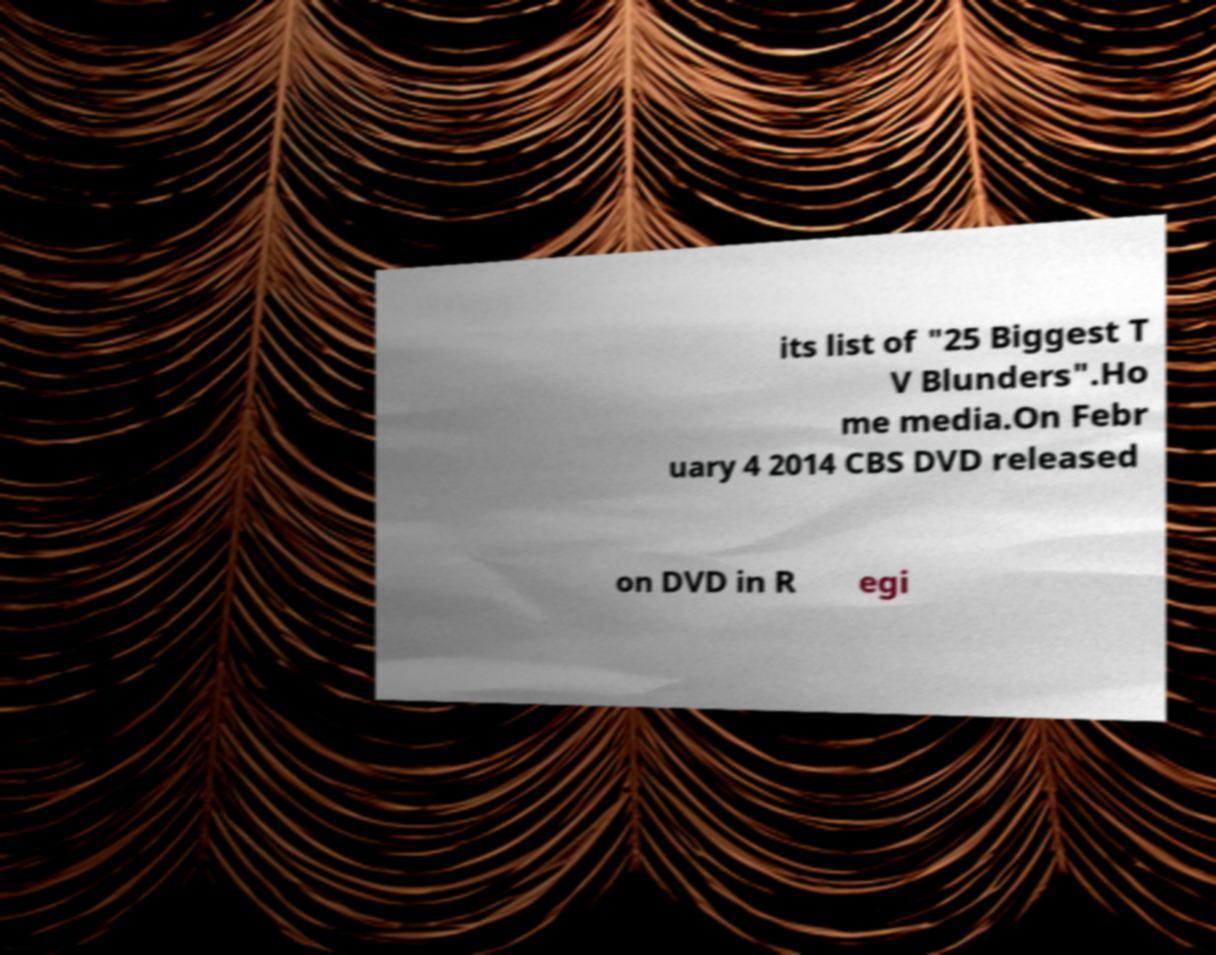Can you read and provide the text displayed in the image?This photo seems to have some interesting text. Can you extract and type it out for me? its list of "25 Biggest T V Blunders".Ho me media.On Febr uary 4 2014 CBS DVD released on DVD in R egi 